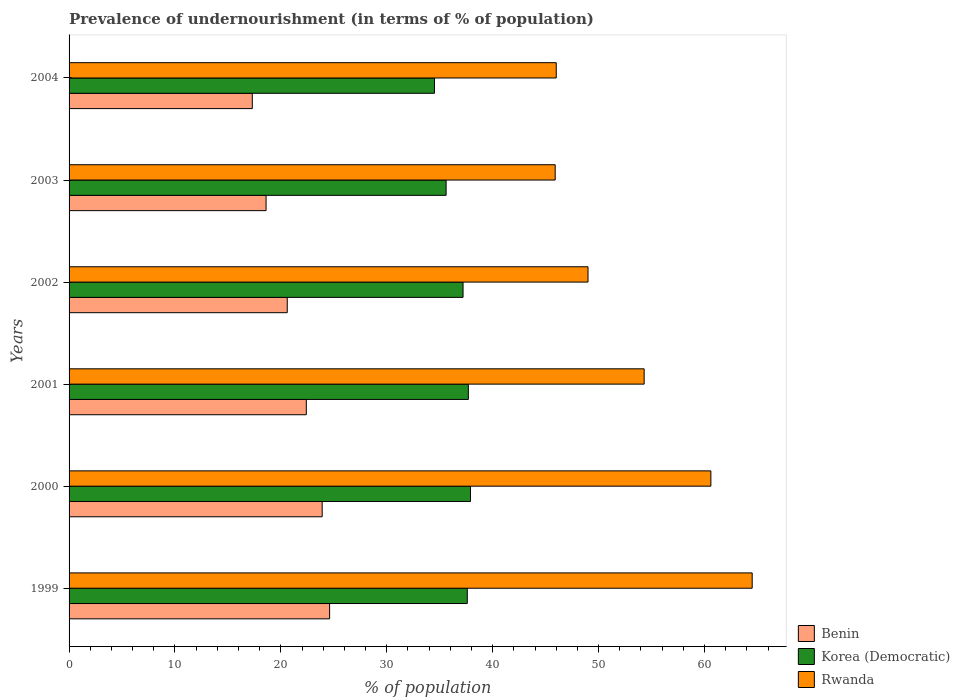How many different coloured bars are there?
Provide a succinct answer. 3. How many groups of bars are there?
Your response must be concise. 6. Are the number of bars per tick equal to the number of legend labels?
Provide a short and direct response. Yes. Are the number of bars on each tick of the Y-axis equal?
Make the answer very short. Yes. How many bars are there on the 1st tick from the top?
Provide a short and direct response. 3. How many bars are there on the 1st tick from the bottom?
Give a very brief answer. 3. In how many cases, is the number of bars for a given year not equal to the number of legend labels?
Your answer should be very brief. 0. Across all years, what is the maximum percentage of undernourished population in Benin?
Your response must be concise. 24.6. Across all years, what is the minimum percentage of undernourished population in Rwanda?
Offer a terse response. 45.9. What is the total percentage of undernourished population in Rwanda in the graph?
Make the answer very short. 320.3. What is the difference between the percentage of undernourished population in Korea (Democratic) in 1999 and that in 2004?
Your answer should be compact. 3.1. What is the difference between the percentage of undernourished population in Korea (Democratic) in 2004 and the percentage of undernourished population in Rwanda in 2001?
Keep it short and to the point. -19.8. What is the average percentage of undernourished population in Rwanda per year?
Your answer should be compact. 53.38. In the year 2001, what is the difference between the percentage of undernourished population in Rwanda and percentage of undernourished population in Korea (Democratic)?
Offer a terse response. 16.6. What is the ratio of the percentage of undernourished population in Korea (Democratic) in 2000 to that in 2001?
Provide a succinct answer. 1.01. Is the percentage of undernourished population in Benin in 2001 less than that in 2004?
Your answer should be compact. No. Is the difference between the percentage of undernourished population in Rwanda in 1999 and 2002 greater than the difference between the percentage of undernourished population in Korea (Democratic) in 1999 and 2002?
Ensure brevity in your answer.  Yes. What is the difference between the highest and the second highest percentage of undernourished population in Korea (Democratic)?
Provide a succinct answer. 0.2. What is the difference between the highest and the lowest percentage of undernourished population in Benin?
Provide a succinct answer. 7.3. In how many years, is the percentage of undernourished population in Korea (Democratic) greater than the average percentage of undernourished population in Korea (Democratic) taken over all years?
Your answer should be very brief. 4. What does the 2nd bar from the top in 1999 represents?
Offer a terse response. Korea (Democratic). What does the 3rd bar from the bottom in 2004 represents?
Your response must be concise. Rwanda. Are the values on the major ticks of X-axis written in scientific E-notation?
Ensure brevity in your answer.  No. Does the graph contain grids?
Your answer should be compact. No. Where does the legend appear in the graph?
Make the answer very short. Bottom right. What is the title of the graph?
Make the answer very short. Prevalence of undernourishment (in terms of % of population). What is the label or title of the X-axis?
Your answer should be compact. % of population. What is the % of population in Benin in 1999?
Offer a terse response. 24.6. What is the % of population in Korea (Democratic) in 1999?
Your answer should be very brief. 37.6. What is the % of population in Rwanda in 1999?
Give a very brief answer. 64.5. What is the % of population of Benin in 2000?
Make the answer very short. 23.9. What is the % of population of Korea (Democratic) in 2000?
Give a very brief answer. 37.9. What is the % of population of Rwanda in 2000?
Give a very brief answer. 60.6. What is the % of population in Benin in 2001?
Your answer should be very brief. 22.4. What is the % of population of Korea (Democratic) in 2001?
Your response must be concise. 37.7. What is the % of population in Rwanda in 2001?
Provide a succinct answer. 54.3. What is the % of population in Benin in 2002?
Your response must be concise. 20.6. What is the % of population of Korea (Democratic) in 2002?
Give a very brief answer. 37.2. What is the % of population of Korea (Democratic) in 2003?
Keep it short and to the point. 35.6. What is the % of population in Rwanda in 2003?
Make the answer very short. 45.9. What is the % of population in Korea (Democratic) in 2004?
Keep it short and to the point. 34.5. What is the % of population in Rwanda in 2004?
Give a very brief answer. 46. Across all years, what is the maximum % of population of Benin?
Your response must be concise. 24.6. Across all years, what is the maximum % of population of Korea (Democratic)?
Your answer should be very brief. 37.9. Across all years, what is the maximum % of population of Rwanda?
Your answer should be very brief. 64.5. Across all years, what is the minimum % of population in Benin?
Your answer should be compact. 17.3. Across all years, what is the minimum % of population of Korea (Democratic)?
Provide a short and direct response. 34.5. Across all years, what is the minimum % of population of Rwanda?
Make the answer very short. 45.9. What is the total % of population of Benin in the graph?
Your answer should be compact. 127.4. What is the total % of population of Korea (Democratic) in the graph?
Offer a very short reply. 220.5. What is the total % of population in Rwanda in the graph?
Offer a very short reply. 320.3. What is the difference between the % of population in Rwanda in 1999 and that in 2000?
Your answer should be very brief. 3.9. What is the difference between the % of population of Benin in 1999 and that in 2001?
Your response must be concise. 2.2. What is the difference between the % of population in Benin in 1999 and that in 2002?
Keep it short and to the point. 4. What is the difference between the % of population of Rwanda in 1999 and that in 2002?
Offer a terse response. 15.5. What is the difference between the % of population of Benin in 1999 and that in 2003?
Your response must be concise. 6. What is the difference between the % of population of Korea (Democratic) in 1999 and that in 2003?
Ensure brevity in your answer.  2. What is the difference between the % of population of Korea (Democratic) in 1999 and that in 2004?
Offer a very short reply. 3.1. What is the difference between the % of population of Rwanda in 1999 and that in 2004?
Give a very brief answer. 18.5. What is the difference between the % of population of Benin in 2000 and that in 2001?
Offer a very short reply. 1.5. What is the difference between the % of population of Rwanda in 2000 and that in 2001?
Provide a short and direct response. 6.3. What is the difference between the % of population of Korea (Democratic) in 2000 and that in 2002?
Offer a very short reply. 0.7. What is the difference between the % of population in Rwanda in 2000 and that in 2002?
Offer a terse response. 11.6. What is the difference between the % of population in Benin in 2000 and that in 2003?
Provide a succinct answer. 5.3. What is the difference between the % of population in Korea (Democratic) in 2000 and that in 2003?
Provide a short and direct response. 2.3. What is the difference between the % of population of Rwanda in 2000 and that in 2004?
Keep it short and to the point. 14.6. What is the difference between the % of population in Benin in 2001 and that in 2003?
Provide a short and direct response. 3.8. What is the difference between the % of population in Rwanda in 2001 and that in 2003?
Keep it short and to the point. 8.4. What is the difference between the % of population of Korea (Democratic) in 2001 and that in 2004?
Provide a succinct answer. 3.2. What is the difference between the % of population of Korea (Democratic) in 2002 and that in 2003?
Your answer should be very brief. 1.6. What is the difference between the % of population of Rwanda in 2002 and that in 2003?
Provide a short and direct response. 3.1. What is the difference between the % of population in Korea (Democratic) in 2003 and that in 2004?
Your answer should be very brief. 1.1. What is the difference between the % of population of Rwanda in 2003 and that in 2004?
Give a very brief answer. -0.1. What is the difference between the % of population of Benin in 1999 and the % of population of Korea (Democratic) in 2000?
Ensure brevity in your answer.  -13.3. What is the difference between the % of population in Benin in 1999 and the % of population in Rwanda in 2000?
Make the answer very short. -36. What is the difference between the % of population in Benin in 1999 and the % of population in Rwanda in 2001?
Ensure brevity in your answer.  -29.7. What is the difference between the % of population of Korea (Democratic) in 1999 and the % of population of Rwanda in 2001?
Give a very brief answer. -16.7. What is the difference between the % of population of Benin in 1999 and the % of population of Rwanda in 2002?
Your answer should be very brief. -24.4. What is the difference between the % of population in Benin in 1999 and the % of population in Korea (Democratic) in 2003?
Keep it short and to the point. -11. What is the difference between the % of population of Benin in 1999 and the % of population of Rwanda in 2003?
Make the answer very short. -21.3. What is the difference between the % of population in Korea (Democratic) in 1999 and the % of population in Rwanda in 2003?
Make the answer very short. -8.3. What is the difference between the % of population in Benin in 1999 and the % of population in Rwanda in 2004?
Provide a succinct answer. -21.4. What is the difference between the % of population of Benin in 2000 and the % of population of Korea (Democratic) in 2001?
Your answer should be very brief. -13.8. What is the difference between the % of population of Benin in 2000 and the % of population of Rwanda in 2001?
Provide a succinct answer. -30.4. What is the difference between the % of population of Korea (Democratic) in 2000 and the % of population of Rwanda in 2001?
Offer a terse response. -16.4. What is the difference between the % of population of Benin in 2000 and the % of population of Rwanda in 2002?
Offer a very short reply. -25.1. What is the difference between the % of population in Korea (Democratic) in 2000 and the % of population in Rwanda in 2002?
Offer a very short reply. -11.1. What is the difference between the % of population of Benin in 2000 and the % of population of Korea (Democratic) in 2003?
Your answer should be compact. -11.7. What is the difference between the % of population of Korea (Democratic) in 2000 and the % of population of Rwanda in 2003?
Give a very brief answer. -8. What is the difference between the % of population in Benin in 2000 and the % of population in Rwanda in 2004?
Your response must be concise. -22.1. What is the difference between the % of population in Korea (Democratic) in 2000 and the % of population in Rwanda in 2004?
Your answer should be very brief. -8.1. What is the difference between the % of population of Benin in 2001 and the % of population of Korea (Democratic) in 2002?
Give a very brief answer. -14.8. What is the difference between the % of population in Benin in 2001 and the % of population in Rwanda in 2002?
Give a very brief answer. -26.6. What is the difference between the % of population of Benin in 2001 and the % of population of Rwanda in 2003?
Your answer should be compact. -23.5. What is the difference between the % of population of Benin in 2001 and the % of population of Korea (Democratic) in 2004?
Provide a short and direct response. -12.1. What is the difference between the % of population of Benin in 2001 and the % of population of Rwanda in 2004?
Your answer should be very brief. -23.6. What is the difference between the % of population of Korea (Democratic) in 2001 and the % of population of Rwanda in 2004?
Your response must be concise. -8.3. What is the difference between the % of population of Benin in 2002 and the % of population of Rwanda in 2003?
Your answer should be very brief. -25.3. What is the difference between the % of population in Korea (Democratic) in 2002 and the % of population in Rwanda in 2003?
Give a very brief answer. -8.7. What is the difference between the % of population in Benin in 2002 and the % of population in Korea (Democratic) in 2004?
Your answer should be very brief. -13.9. What is the difference between the % of population in Benin in 2002 and the % of population in Rwanda in 2004?
Offer a terse response. -25.4. What is the difference between the % of population of Korea (Democratic) in 2002 and the % of population of Rwanda in 2004?
Give a very brief answer. -8.8. What is the difference between the % of population of Benin in 2003 and the % of population of Korea (Democratic) in 2004?
Offer a terse response. -15.9. What is the difference between the % of population in Benin in 2003 and the % of population in Rwanda in 2004?
Make the answer very short. -27.4. What is the average % of population in Benin per year?
Your response must be concise. 21.23. What is the average % of population of Korea (Democratic) per year?
Offer a very short reply. 36.75. What is the average % of population of Rwanda per year?
Provide a short and direct response. 53.38. In the year 1999, what is the difference between the % of population of Benin and % of population of Rwanda?
Make the answer very short. -39.9. In the year 1999, what is the difference between the % of population in Korea (Democratic) and % of population in Rwanda?
Give a very brief answer. -26.9. In the year 2000, what is the difference between the % of population in Benin and % of population in Korea (Democratic)?
Ensure brevity in your answer.  -14. In the year 2000, what is the difference between the % of population of Benin and % of population of Rwanda?
Your answer should be very brief. -36.7. In the year 2000, what is the difference between the % of population of Korea (Democratic) and % of population of Rwanda?
Provide a succinct answer. -22.7. In the year 2001, what is the difference between the % of population of Benin and % of population of Korea (Democratic)?
Give a very brief answer. -15.3. In the year 2001, what is the difference between the % of population of Benin and % of population of Rwanda?
Keep it short and to the point. -31.9. In the year 2001, what is the difference between the % of population in Korea (Democratic) and % of population in Rwanda?
Your answer should be very brief. -16.6. In the year 2002, what is the difference between the % of population in Benin and % of population in Korea (Democratic)?
Make the answer very short. -16.6. In the year 2002, what is the difference between the % of population of Benin and % of population of Rwanda?
Provide a short and direct response. -28.4. In the year 2003, what is the difference between the % of population of Benin and % of population of Rwanda?
Your response must be concise. -27.3. In the year 2004, what is the difference between the % of population in Benin and % of population in Korea (Democratic)?
Give a very brief answer. -17.2. In the year 2004, what is the difference between the % of population of Benin and % of population of Rwanda?
Ensure brevity in your answer.  -28.7. In the year 2004, what is the difference between the % of population in Korea (Democratic) and % of population in Rwanda?
Keep it short and to the point. -11.5. What is the ratio of the % of population in Benin in 1999 to that in 2000?
Provide a succinct answer. 1.03. What is the ratio of the % of population of Rwanda in 1999 to that in 2000?
Provide a short and direct response. 1.06. What is the ratio of the % of population of Benin in 1999 to that in 2001?
Keep it short and to the point. 1.1. What is the ratio of the % of population in Rwanda in 1999 to that in 2001?
Provide a succinct answer. 1.19. What is the ratio of the % of population of Benin in 1999 to that in 2002?
Your response must be concise. 1.19. What is the ratio of the % of population of Korea (Democratic) in 1999 to that in 2002?
Your response must be concise. 1.01. What is the ratio of the % of population of Rwanda in 1999 to that in 2002?
Provide a short and direct response. 1.32. What is the ratio of the % of population of Benin in 1999 to that in 2003?
Your answer should be very brief. 1.32. What is the ratio of the % of population of Korea (Democratic) in 1999 to that in 2003?
Offer a very short reply. 1.06. What is the ratio of the % of population of Rwanda in 1999 to that in 2003?
Offer a terse response. 1.41. What is the ratio of the % of population in Benin in 1999 to that in 2004?
Your answer should be very brief. 1.42. What is the ratio of the % of population of Korea (Democratic) in 1999 to that in 2004?
Give a very brief answer. 1.09. What is the ratio of the % of population of Rwanda in 1999 to that in 2004?
Your response must be concise. 1.4. What is the ratio of the % of population in Benin in 2000 to that in 2001?
Make the answer very short. 1.07. What is the ratio of the % of population of Korea (Democratic) in 2000 to that in 2001?
Provide a short and direct response. 1.01. What is the ratio of the % of population of Rwanda in 2000 to that in 2001?
Offer a very short reply. 1.12. What is the ratio of the % of population in Benin in 2000 to that in 2002?
Offer a very short reply. 1.16. What is the ratio of the % of population of Korea (Democratic) in 2000 to that in 2002?
Ensure brevity in your answer.  1.02. What is the ratio of the % of population of Rwanda in 2000 to that in 2002?
Provide a short and direct response. 1.24. What is the ratio of the % of population of Benin in 2000 to that in 2003?
Provide a succinct answer. 1.28. What is the ratio of the % of population of Korea (Democratic) in 2000 to that in 2003?
Keep it short and to the point. 1.06. What is the ratio of the % of population in Rwanda in 2000 to that in 2003?
Ensure brevity in your answer.  1.32. What is the ratio of the % of population of Benin in 2000 to that in 2004?
Offer a terse response. 1.38. What is the ratio of the % of population of Korea (Democratic) in 2000 to that in 2004?
Give a very brief answer. 1.1. What is the ratio of the % of population in Rwanda in 2000 to that in 2004?
Provide a short and direct response. 1.32. What is the ratio of the % of population in Benin in 2001 to that in 2002?
Ensure brevity in your answer.  1.09. What is the ratio of the % of population of Korea (Democratic) in 2001 to that in 2002?
Ensure brevity in your answer.  1.01. What is the ratio of the % of population in Rwanda in 2001 to that in 2002?
Give a very brief answer. 1.11. What is the ratio of the % of population of Benin in 2001 to that in 2003?
Offer a terse response. 1.2. What is the ratio of the % of population of Korea (Democratic) in 2001 to that in 2003?
Give a very brief answer. 1.06. What is the ratio of the % of population of Rwanda in 2001 to that in 2003?
Make the answer very short. 1.18. What is the ratio of the % of population in Benin in 2001 to that in 2004?
Your answer should be compact. 1.29. What is the ratio of the % of population in Korea (Democratic) in 2001 to that in 2004?
Keep it short and to the point. 1.09. What is the ratio of the % of population in Rwanda in 2001 to that in 2004?
Keep it short and to the point. 1.18. What is the ratio of the % of population in Benin in 2002 to that in 2003?
Offer a terse response. 1.11. What is the ratio of the % of population of Korea (Democratic) in 2002 to that in 2003?
Provide a succinct answer. 1.04. What is the ratio of the % of population in Rwanda in 2002 to that in 2003?
Offer a terse response. 1.07. What is the ratio of the % of population in Benin in 2002 to that in 2004?
Your response must be concise. 1.19. What is the ratio of the % of population in Korea (Democratic) in 2002 to that in 2004?
Offer a very short reply. 1.08. What is the ratio of the % of population in Rwanda in 2002 to that in 2004?
Provide a succinct answer. 1.07. What is the ratio of the % of population in Benin in 2003 to that in 2004?
Make the answer very short. 1.08. What is the ratio of the % of population of Korea (Democratic) in 2003 to that in 2004?
Your response must be concise. 1.03. What is the difference between the highest and the second highest % of population in Rwanda?
Offer a very short reply. 3.9. What is the difference between the highest and the lowest % of population of Benin?
Your answer should be very brief. 7.3. What is the difference between the highest and the lowest % of population in Korea (Democratic)?
Provide a succinct answer. 3.4. What is the difference between the highest and the lowest % of population in Rwanda?
Give a very brief answer. 18.6. 